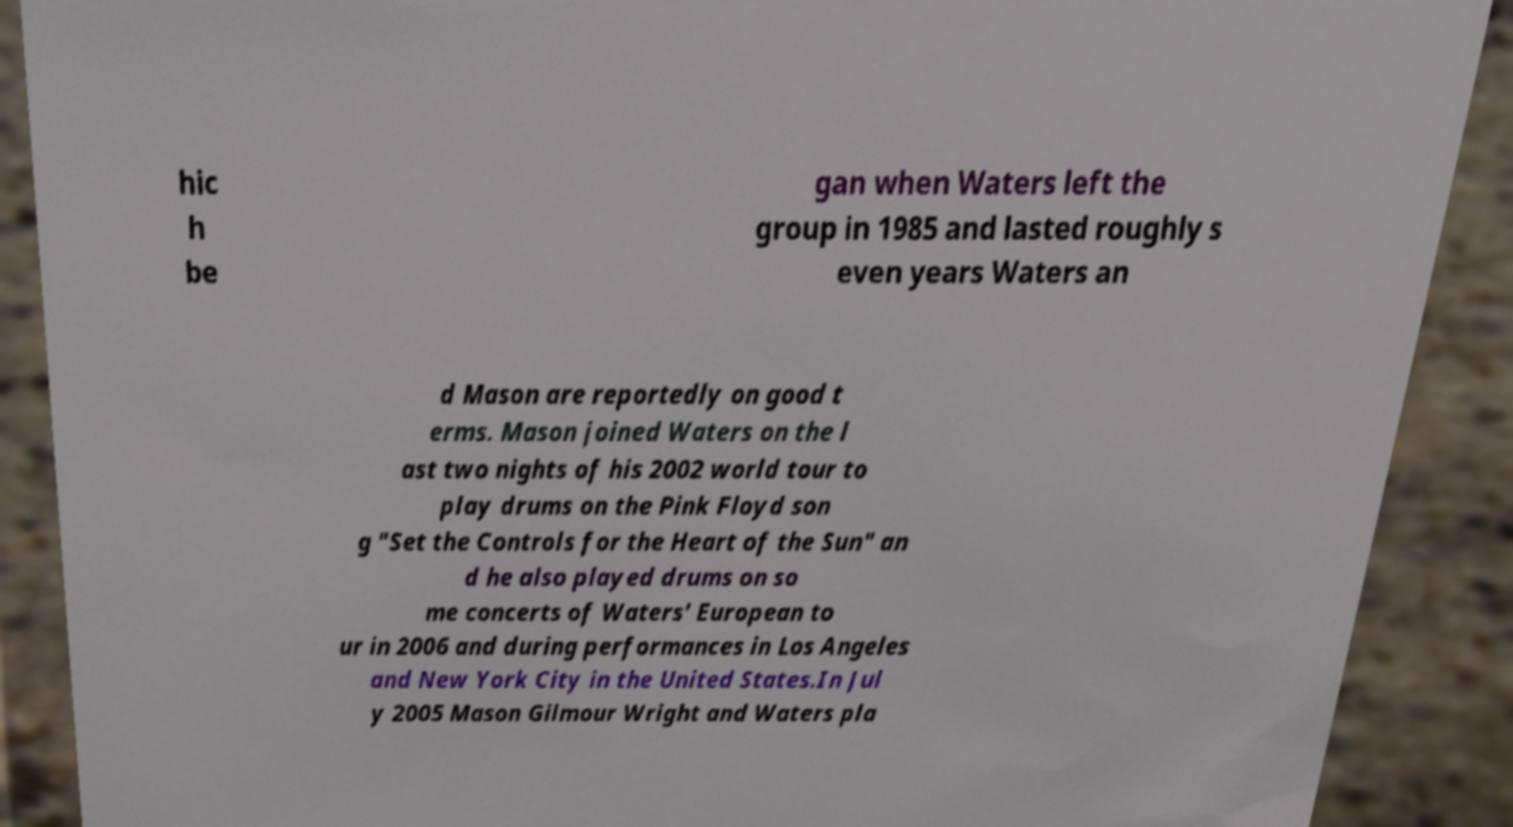Please read and relay the text visible in this image. What does it say? hic h be gan when Waters left the group in 1985 and lasted roughly s even years Waters an d Mason are reportedly on good t erms. Mason joined Waters on the l ast two nights of his 2002 world tour to play drums on the Pink Floyd son g "Set the Controls for the Heart of the Sun" an d he also played drums on so me concerts of Waters' European to ur in 2006 and during performances in Los Angeles and New York City in the United States.In Jul y 2005 Mason Gilmour Wright and Waters pla 